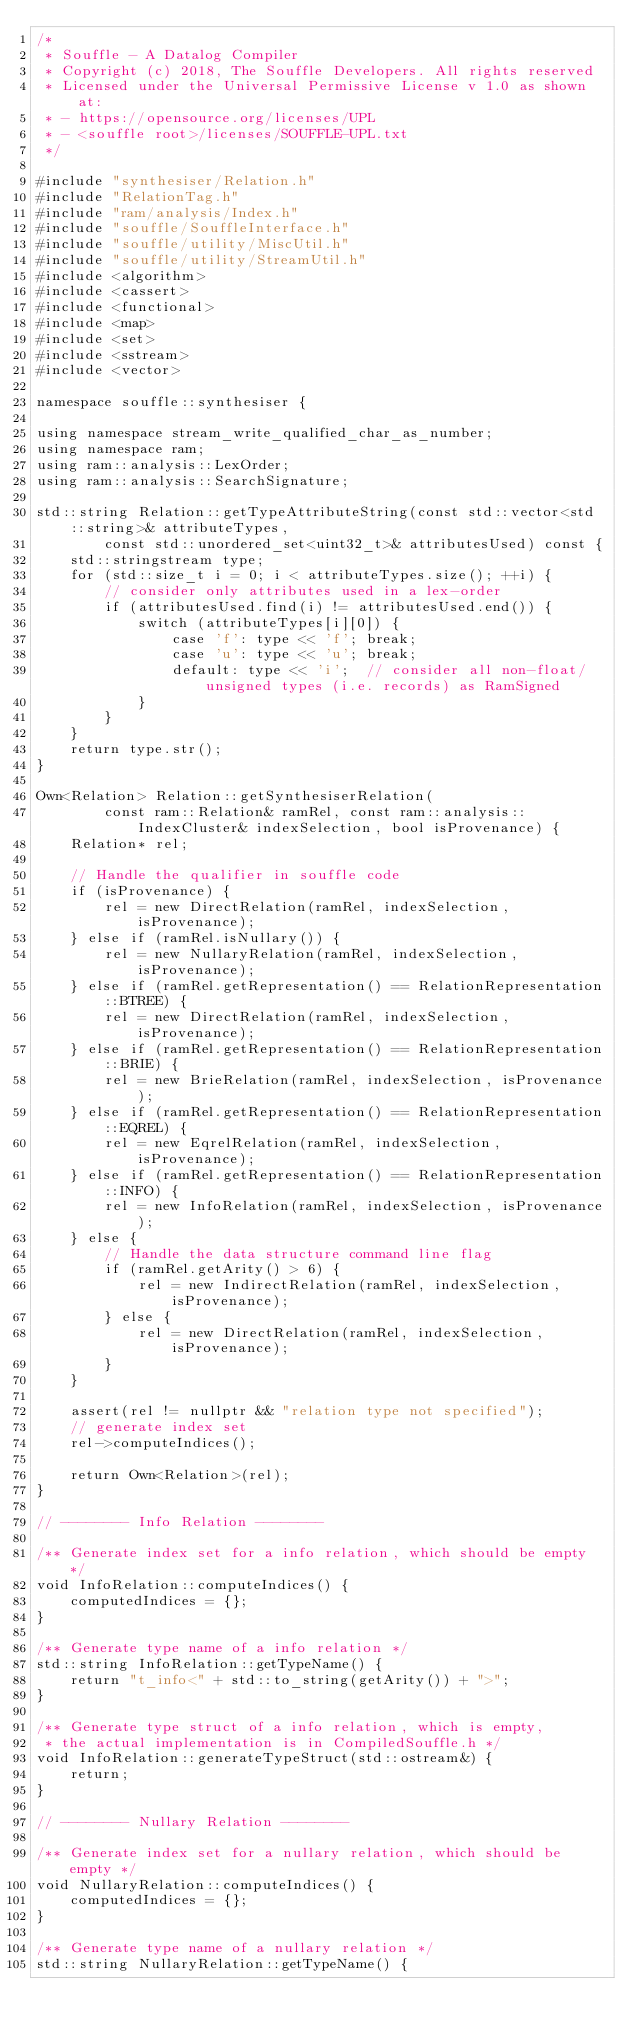<code> <loc_0><loc_0><loc_500><loc_500><_C++_>/*
 * Souffle - A Datalog Compiler
 * Copyright (c) 2018, The Souffle Developers. All rights reserved
 * Licensed under the Universal Permissive License v 1.0 as shown at:
 * - https://opensource.org/licenses/UPL
 * - <souffle root>/licenses/SOUFFLE-UPL.txt
 */

#include "synthesiser/Relation.h"
#include "RelationTag.h"
#include "ram/analysis/Index.h"
#include "souffle/SouffleInterface.h"
#include "souffle/utility/MiscUtil.h"
#include "souffle/utility/StreamUtil.h"
#include <algorithm>
#include <cassert>
#include <functional>
#include <map>
#include <set>
#include <sstream>
#include <vector>

namespace souffle::synthesiser {

using namespace stream_write_qualified_char_as_number;
using namespace ram;
using ram::analysis::LexOrder;
using ram::analysis::SearchSignature;

std::string Relation::getTypeAttributeString(const std::vector<std::string>& attributeTypes,
        const std::unordered_set<uint32_t>& attributesUsed) const {
    std::stringstream type;
    for (std::size_t i = 0; i < attributeTypes.size(); ++i) {
        // consider only attributes used in a lex-order
        if (attributesUsed.find(i) != attributesUsed.end()) {
            switch (attributeTypes[i][0]) {
                case 'f': type << 'f'; break;
                case 'u': type << 'u'; break;
                default: type << 'i';  // consider all non-float/unsigned types (i.e. records) as RamSigned
            }
        }
    }
    return type.str();
}

Own<Relation> Relation::getSynthesiserRelation(
        const ram::Relation& ramRel, const ram::analysis::IndexCluster& indexSelection, bool isProvenance) {
    Relation* rel;

    // Handle the qualifier in souffle code
    if (isProvenance) {
        rel = new DirectRelation(ramRel, indexSelection, isProvenance);
    } else if (ramRel.isNullary()) {
        rel = new NullaryRelation(ramRel, indexSelection, isProvenance);
    } else if (ramRel.getRepresentation() == RelationRepresentation::BTREE) {
        rel = new DirectRelation(ramRel, indexSelection, isProvenance);
    } else if (ramRel.getRepresentation() == RelationRepresentation::BRIE) {
        rel = new BrieRelation(ramRel, indexSelection, isProvenance);
    } else if (ramRel.getRepresentation() == RelationRepresentation::EQREL) {
        rel = new EqrelRelation(ramRel, indexSelection, isProvenance);
    } else if (ramRel.getRepresentation() == RelationRepresentation::INFO) {
        rel = new InfoRelation(ramRel, indexSelection, isProvenance);
    } else {
        // Handle the data structure command line flag
        if (ramRel.getArity() > 6) {
            rel = new IndirectRelation(ramRel, indexSelection, isProvenance);
        } else {
            rel = new DirectRelation(ramRel, indexSelection, isProvenance);
        }
    }

    assert(rel != nullptr && "relation type not specified");
    // generate index set
    rel->computeIndices();

    return Own<Relation>(rel);
}

// -------- Info Relation --------

/** Generate index set for a info relation, which should be empty */
void InfoRelation::computeIndices() {
    computedIndices = {};
}

/** Generate type name of a info relation */
std::string InfoRelation::getTypeName() {
    return "t_info<" + std::to_string(getArity()) + ">";
}

/** Generate type struct of a info relation, which is empty,
 * the actual implementation is in CompiledSouffle.h */
void InfoRelation::generateTypeStruct(std::ostream&) {
    return;
}

// -------- Nullary Relation --------

/** Generate index set for a nullary relation, which should be empty */
void NullaryRelation::computeIndices() {
    computedIndices = {};
}

/** Generate type name of a nullary relation */
std::string NullaryRelation::getTypeName() {</code> 